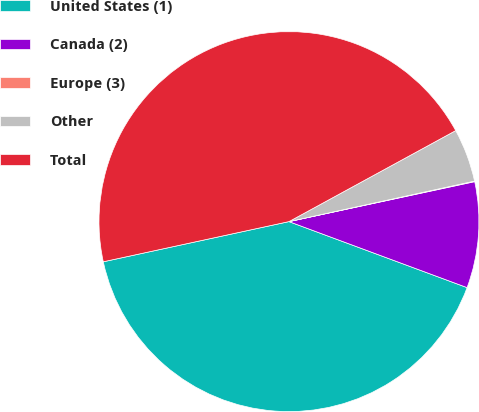<chart> <loc_0><loc_0><loc_500><loc_500><pie_chart><fcel>United States (1)<fcel>Canada (2)<fcel>Europe (3)<fcel>Other<fcel>Total<nl><fcel>40.96%<fcel>9.02%<fcel>0.05%<fcel>4.53%<fcel>45.44%<nl></chart> 